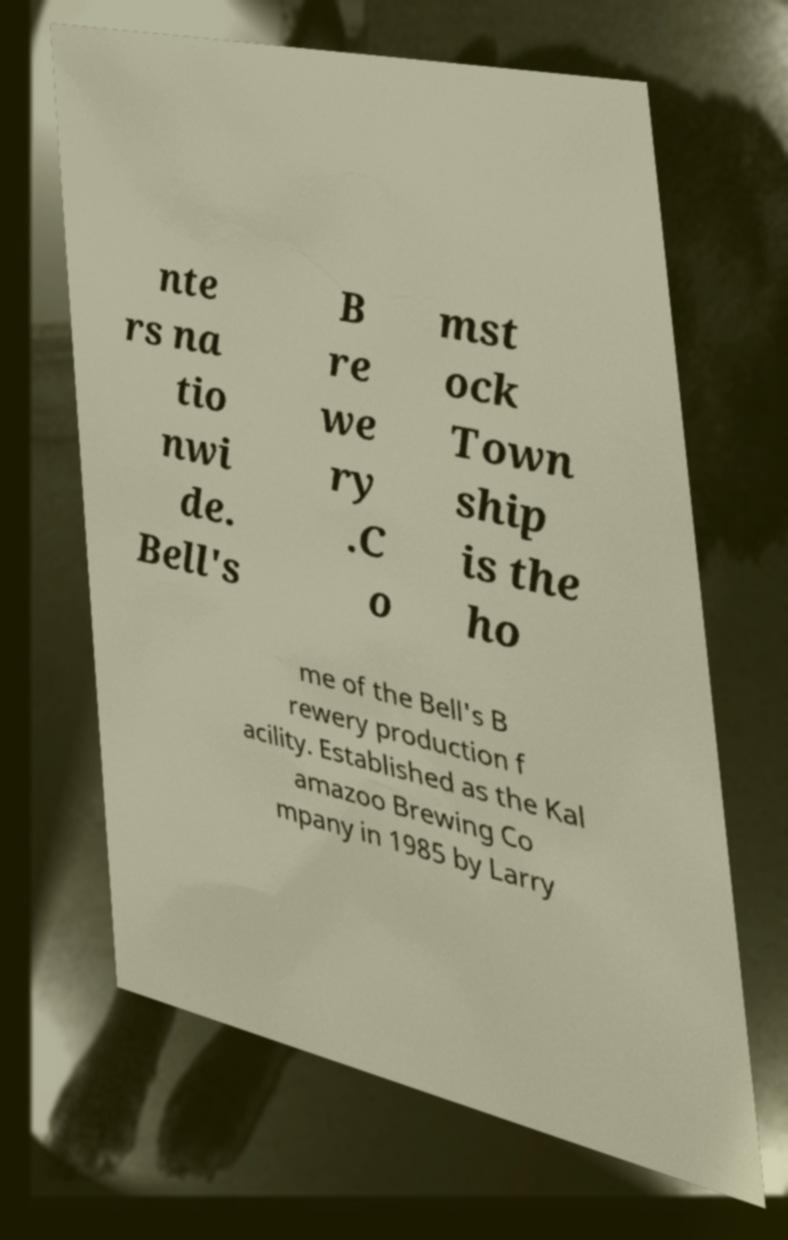There's text embedded in this image that I need extracted. Can you transcribe it verbatim? nte rs na tio nwi de. Bell's B re we ry .C o mst ock Town ship is the ho me of the Bell's B rewery production f acility. Established as the Kal amazoo Brewing Co mpany in 1985 by Larry 